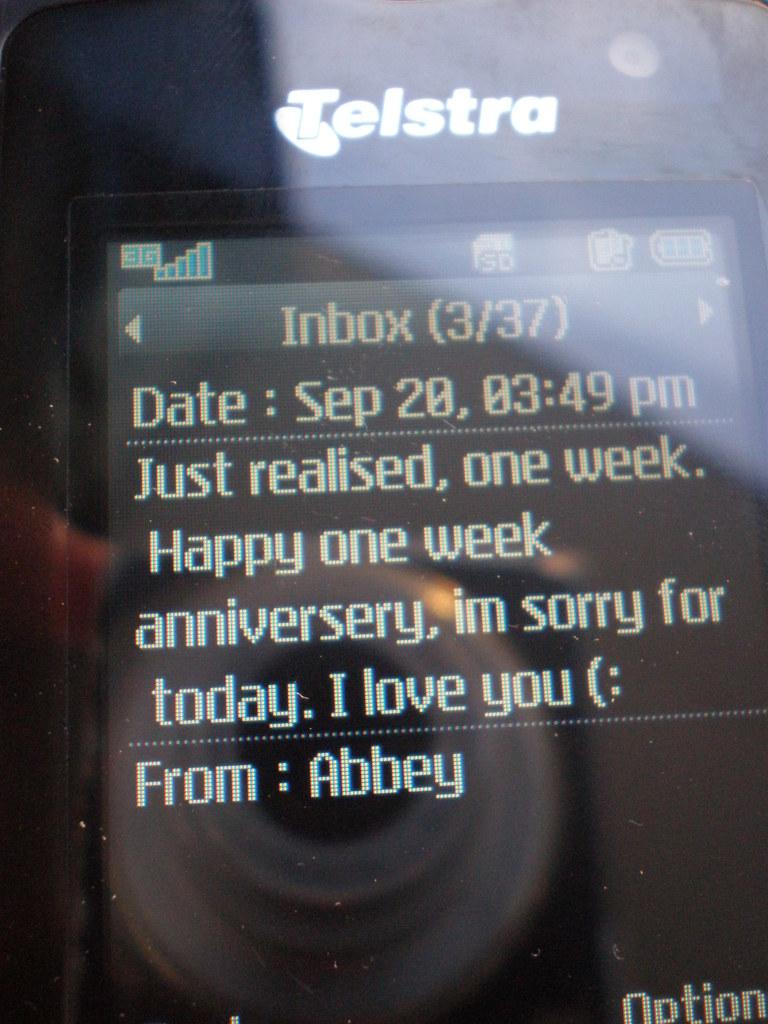<image>
Render a clear and concise summary of the photo. An anniversary text message sent on September 20th rom Abbey. 